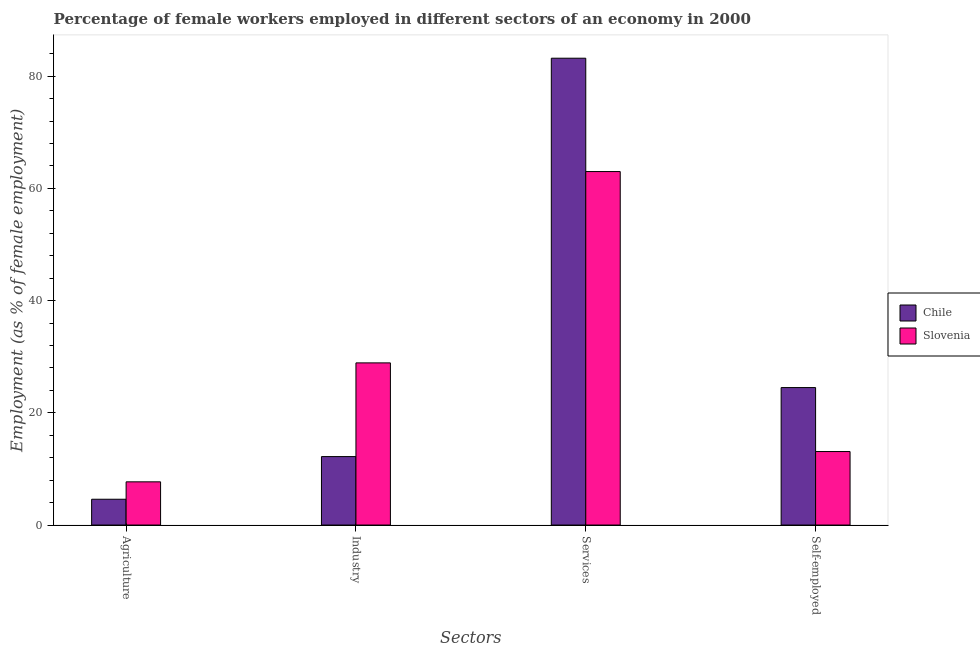How many different coloured bars are there?
Offer a very short reply. 2. How many groups of bars are there?
Provide a succinct answer. 4. Are the number of bars per tick equal to the number of legend labels?
Provide a succinct answer. Yes. Are the number of bars on each tick of the X-axis equal?
Your answer should be compact. Yes. How many bars are there on the 1st tick from the left?
Your answer should be very brief. 2. How many bars are there on the 3rd tick from the right?
Your answer should be very brief. 2. What is the label of the 4th group of bars from the left?
Offer a very short reply. Self-employed. What is the percentage of female workers in industry in Slovenia?
Offer a terse response. 28.9. Across all countries, what is the maximum percentage of female workers in industry?
Give a very brief answer. 28.9. Across all countries, what is the minimum percentage of self employed female workers?
Offer a terse response. 13.1. In which country was the percentage of female workers in industry maximum?
Make the answer very short. Slovenia. What is the total percentage of female workers in industry in the graph?
Offer a terse response. 41.1. What is the difference between the percentage of female workers in agriculture in Chile and that in Slovenia?
Provide a short and direct response. -3.1. What is the difference between the percentage of female workers in industry in Chile and the percentage of female workers in agriculture in Slovenia?
Provide a succinct answer. 4.5. What is the average percentage of female workers in agriculture per country?
Your answer should be very brief. 6.15. What is the difference between the percentage of female workers in services and percentage of self employed female workers in Chile?
Give a very brief answer. 58.7. In how many countries, is the percentage of female workers in industry greater than 64 %?
Offer a terse response. 0. What is the ratio of the percentage of female workers in services in Chile to that in Slovenia?
Offer a terse response. 1.32. Is the percentage of female workers in agriculture in Slovenia less than that in Chile?
Your answer should be compact. No. Is the difference between the percentage of self employed female workers in Slovenia and Chile greater than the difference between the percentage of female workers in services in Slovenia and Chile?
Offer a terse response. Yes. What is the difference between the highest and the second highest percentage of self employed female workers?
Keep it short and to the point. 11.4. What is the difference between the highest and the lowest percentage of self employed female workers?
Make the answer very short. 11.4. In how many countries, is the percentage of self employed female workers greater than the average percentage of self employed female workers taken over all countries?
Ensure brevity in your answer.  1. Is it the case that in every country, the sum of the percentage of female workers in agriculture and percentage of female workers in industry is greater than the sum of percentage of self employed female workers and percentage of female workers in services?
Offer a terse response. No. What does the 2nd bar from the left in Services represents?
Provide a succinct answer. Slovenia. What does the 1st bar from the right in Agriculture represents?
Give a very brief answer. Slovenia. Are all the bars in the graph horizontal?
Ensure brevity in your answer.  No. What is the difference between two consecutive major ticks on the Y-axis?
Make the answer very short. 20. Are the values on the major ticks of Y-axis written in scientific E-notation?
Your response must be concise. No. Does the graph contain any zero values?
Ensure brevity in your answer.  No. Does the graph contain grids?
Offer a very short reply. No. Where does the legend appear in the graph?
Provide a succinct answer. Center right. How many legend labels are there?
Your answer should be compact. 2. What is the title of the graph?
Ensure brevity in your answer.  Percentage of female workers employed in different sectors of an economy in 2000. Does "Estonia" appear as one of the legend labels in the graph?
Keep it short and to the point. No. What is the label or title of the X-axis?
Provide a succinct answer. Sectors. What is the label or title of the Y-axis?
Provide a succinct answer. Employment (as % of female employment). What is the Employment (as % of female employment) in Chile in Agriculture?
Offer a terse response. 4.6. What is the Employment (as % of female employment) in Slovenia in Agriculture?
Offer a very short reply. 7.7. What is the Employment (as % of female employment) in Chile in Industry?
Your answer should be very brief. 12.2. What is the Employment (as % of female employment) of Slovenia in Industry?
Make the answer very short. 28.9. What is the Employment (as % of female employment) of Chile in Services?
Your answer should be compact. 83.2. What is the Employment (as % of female employment) of Slovenia in Services?
Give a very brief answer. 63. What is the Employment (as % of female employment) of Slovenia in Self-employed?
Ensure brevity in your answer.  13.1. Across all Sectors, what is the maximum Employment (as % of female employment) of Chile?
Ensure brevity in your answer.  83.2. Across all Sectors, what is the minimum Employment (as % of female employment) in Chile?
Your answer should be compact. 4.6. Across all Sectors, what is the minimum Employment (as % of female employment) in Slovenia?
Your response must be concise. 7.7. What is the total Employment (as % of female employment) of Chile in the graph?
Your answer should be compact. 124.5. What is the total Employment (as % of female employment) of Slovenia in the graph?
Offer a very short reply. 112.7. What is the difference between the Employment (as % of female employment) of Chile in Agriculture and that in Industry?
Offer a very short reply. -7.6. What is the difference between the Employment (as % of female employment) in Slovenia in Agriculture and that in Industry?
Give a very brief answer. -21.2. What is the difference between the Employment (as % of female employment) in Chile in Agriculture and that in Services?
Make the answer very short. -78.6. What is the difference between the Employment (as % of female employment) of Slovenia in Agriculture and that in Services?
Provide a succinct answer. -55.3. What is the difference between the Employment (as % of female employment) in Chile in Agriculture and that in Self-employed?
Your answer should be compact. -19.9. What is the difference between the Employment (as % of female employment) in Chile in Industry and that in Services?
Give a very brief answer. -71. What is the difference between the Employment (as % of female employment) of Slovenia in Industry and that in Services?
Your answer should be very brief. -34.1. What is the difference between the Employment (as % of female employment) of Chile in Services and that in Self-employed?
Provide a short and direct response. 58.7. What is the difference between the Employment (as % of female employment) in Slovenia in Services and that in Self-employed?
Ensure brevity in your answer.  49.9. What is the difference between the Employment (as % of female employment) in Chile in Agriculture and the Employment (as % of female employment) in Slovenia in Industry?
Make the answer very short. -24.3. What is the difference between the Employment (as % of female employment) in Chile in Agriculture and the Employment (as % of female employment) in Slovenia in Services?
Provide a succinct answer. -58.4. What is the difference between the Employment (as % of female employment) of Chile in Agriculture and the Employment (as % of female employment) of Slovenia in Self-employed?
Keep it short and to the point. -8.5. What is the difference between the Employment (as % of female employment) in Chile in Industry and the Employment (as % of female employment) in Slovenia in Services?
Your answer should be very brief. -50.8. What is the difference between the Employment (as % of female employment) in Chile in Services and the Employment (as % of female employment) in Slovenia in Self-employed?
Provide a short and direct response. 70.1. What is the average Employment (as % of female employment) of Chile per Sectors?
Your response must be concise. 31.12. What is the average Employment (as % of female employment) in Slovenia per Sectors?
Provide a short and direct response. 28.18. What is the difference between the Employment (as % of female employment) of Chile and Employment (as % of female employment) of Slovenia in Agriculture?
Make the answer very short. -3.1. What is the difference between the Employment (as % of female employment) in Chile and Employment (as % of female employment) in Slovenia in Industry?
Your response must be concise. -16.7. What is the difference between the Employment (as % of female employment) in Chile and Employment (as % of female employment) in Slovenia in Services?
Keep it short and to the point. 20.2. What is the difference between the Employment (as % of female employment) of Chile and Employment (as % of female employment) of Slovenia in Self-employed?
Provide a short and direct response. 11.4. What is the ratio of the Employment (as % of female employment) in Chile in Agriculture to that in Industry?
Make the answer very short. 0.38. What is the ratio of the Employment (as % of female employment) of Slovenia in Agriculture to that in Industry?
Provide a short and direct response. 0.27. What is the ratio of the Employment (as % of female employment) in Chile in Agriculture to that in Services?
Your response must be concise. 0.06. What is the ratio of the Employment (as % of female employment) of Slovenia in Agriculture to that in Services?
Offer a very short reply. 0.12. What is the ratio of the Employment (as % of female employment) of Chile in Agriculture to that in Self-employed?
Your answer should be very brief. 0.19. What is the ratio of the Employment (as % of female employment) in Slovenia in Agriculture to that in Self-employed?
Make the answer very short. 0.59. What is the ratio of the Employment (as % of female employment) in Chile in Industry to that in Services?
Provide a short and direct response. 0.15. What is the ratio of the Employment (as % of female employment) of Slovenia in Industry to that in Services?
Your answer should be compact. 0.46. What is the ratio of the Employment (as % of female employment) in Chile in Industry to that in Self-employed?
Ensure brevity in your answer.  0.5. What is the ratio of the Employment (as % of female employment) of Slovenia in Industry to that in Self-employed?
Give a very brief answer. 2.21. What is the ratio of the Employment (as % of female employment) in Chile in Services to that in Self-employed?
Your response must be concise. 3.4. What is the ratio of the Employment (as % of female employment) in Slovenia in Services to that in Self-employed?
Provide a short and direct response. 4.81. What is the difference between the highest and the second highest Employment (as % of female employment) in Chile?
Provide a short and direct response. 58.7. What is the difference between the highest and the second highest Employment (as % of female employment) of Slovenia?
Your answer should be very brief. 34.1. What is the difference between the highest and the lowest Employment (as % of female employment) of Chile?
Keep it short and to the point. 78.6. What is the difference between the highest and the lowest Employment (as % of female employment) of Slovenia?
Your answer should be very brief. 55.3. 